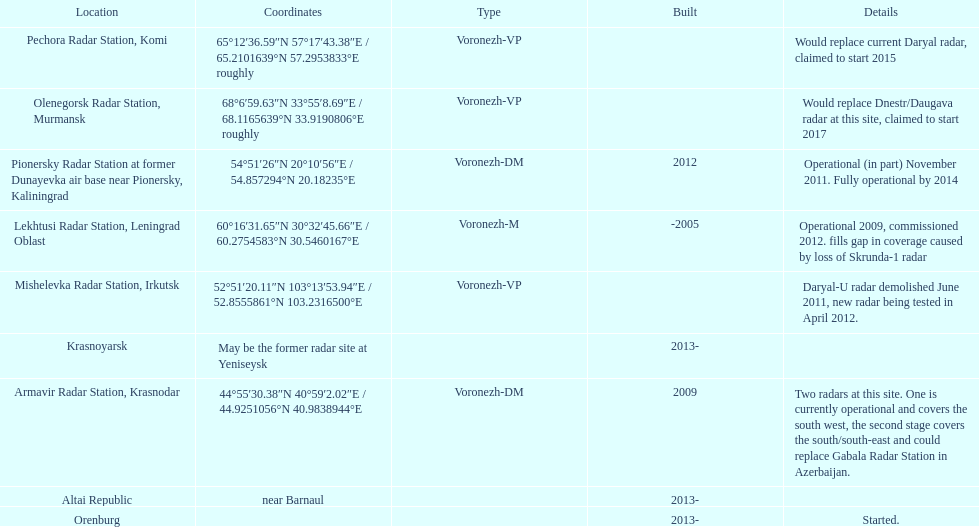How long did it take the pionersky radar station to go from partially operational to fully operational? 3 years. 